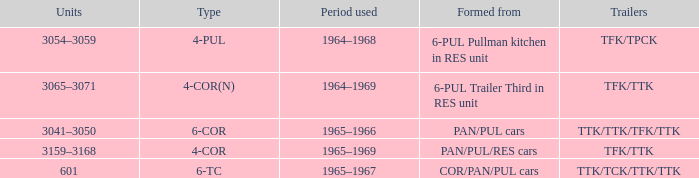Name the typed for formed from 6-pul trailer third in res unit 4-COR(N). Can you parse all the data within this table? {'header': ['Units', 'Type', 'Period used', 'Formed from', 'Trailers'], 'rows': [['3054–3059', '4-PUL', '1964–1968', '6-PUL Pullman kitchen in RES unit', 'TFK/TPCK'], ['3065–3071', '4-COR(N)', '1964–1969', '6-PUL Trailer Third in RES unit', 'TFK/TTK'], ['3041–3050', '6-COR', '1965–1966', 'PAN/PUL cars', 'TTK/TTK/TFK/TTK'], ['3159–3168', '4-COR', '1965–1969', 'PAN/PUL/RES cars', 'TFK/TTK'], ['601', '6-TC', '1965–1967', 'COR/PAN/PUL cars', 'TTK/TCK/TTK/TTK']]} 